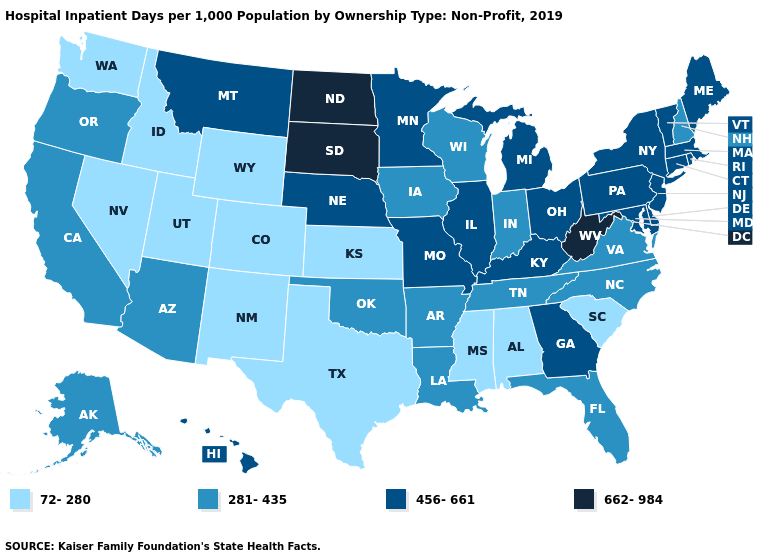Does Alaska have a lower value than Vermont?
Concise answer only. Yes. Name the states that have a value in the range 281-435?
Keep it brief. Alaska, Arizona, Arkansas, California, Florida, Indiana, Iowa, Louisiana, New Hampshire, North Carolina, Oklahoma, Oregon, Tennessee, Virginia, Wisconsin. What is the lowest value in the MidWest?
Concise answer only. 72-280. Among the states that border Kentucky , which have the highest value?
Concise answer only. West Virginia. Is the legend a continuous bar?
Quick response, please. No. Name the states that have a value in the range 662-984?
Write a very short answer. North Dakota, South Dakota, West Virginia. What is the value of Alabama?
Write a very short answer. 72-280. Does Mississippi have a lower value than Washington?
Concise answer only. No. Which states have the highest value in the USA?
Short answer required. North Dakota, South Dakota, West Virginia. Does Florida have a lower value than Oregon?
Concise answer only. No. Does Massachusetts have the same value as South Dakota?
Short answer required. No. What is the highest value in the USA?
Be succinct. 662-984. What is the value of Georgia?
Concise answer only. 456-661. How many symbols are there in the legend?
Short answer required. 4. 